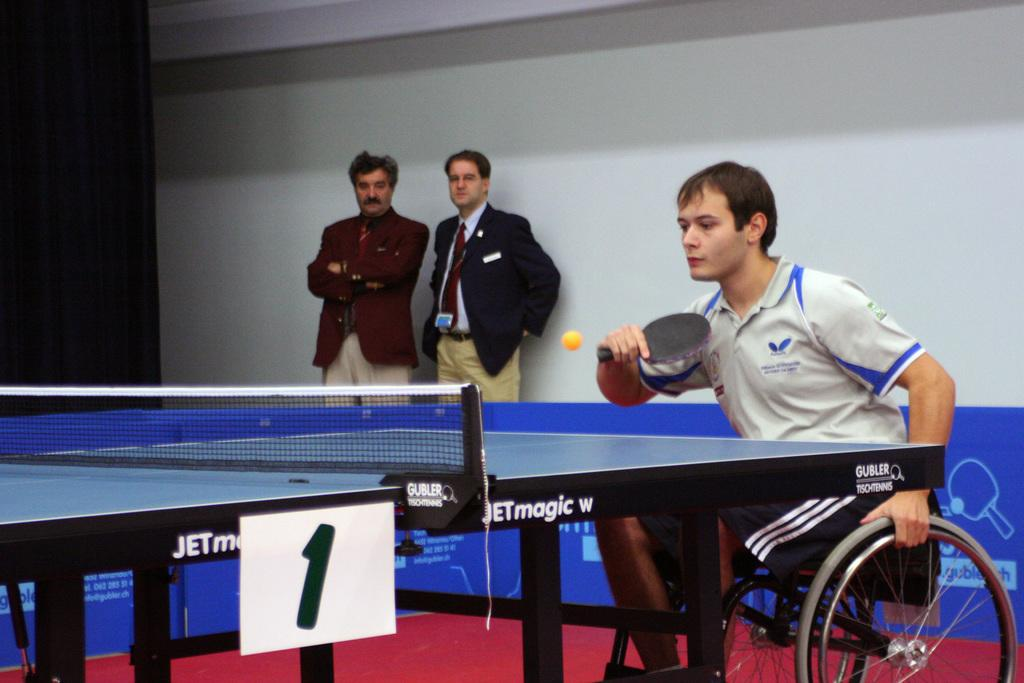What is the person in the image wearing? The person in the image is wearing a white t-shirt. What is the person in the white t-shirt doing? The person is sitting and playing a game. How many other people are in the image? There are two other persons in the image. What are the two other persons doing? The two other persons are looking at the person who is playing the game. What type of bird can be seen flying in the image? There is no bird visible in the image. What riddle is the person in the white t-shirt trying to solve while playing the game? The provided facts do not mention a riddle being involved in the game. 